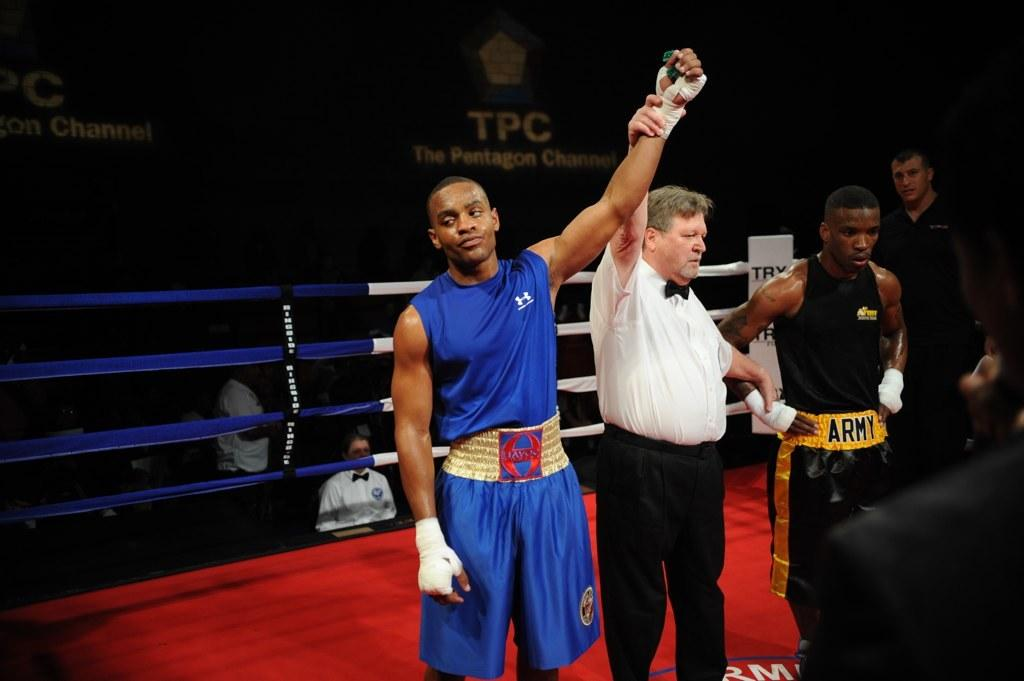Provide a one-sentence caption for the provided image. A boxing referee is holding up the winner's hand and the loser has a belt that says Army. 